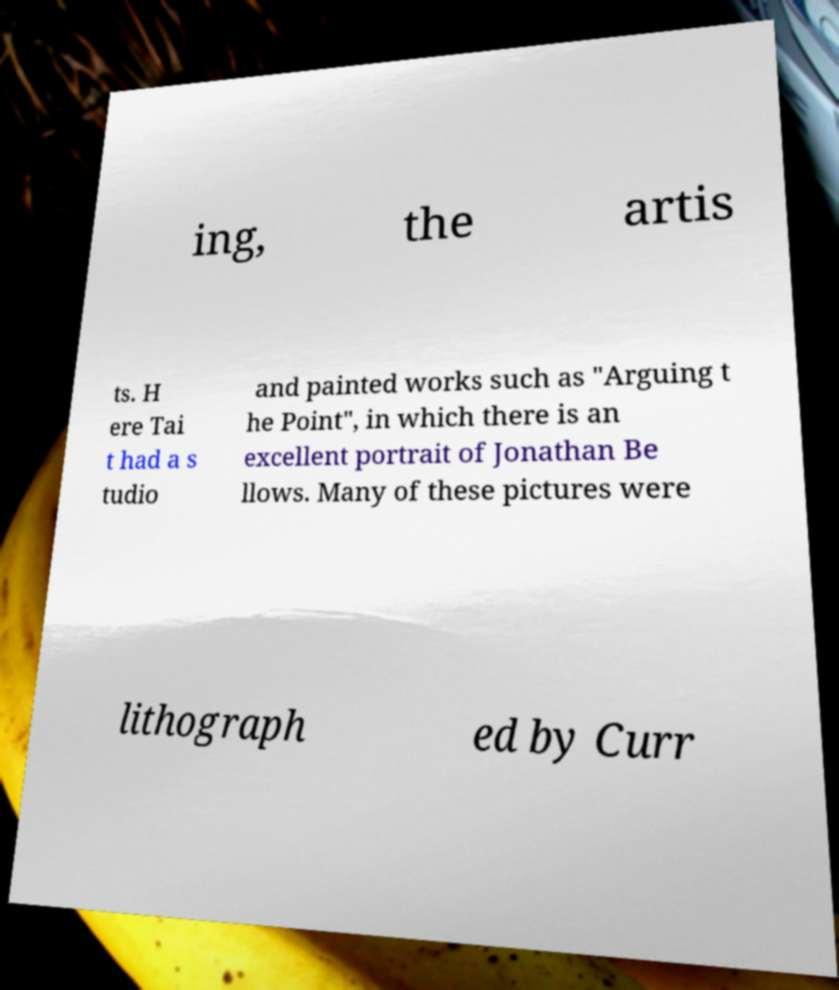Could you assist in decoding the text presented in this image and type it out clearly? ing, the artis ts. H ere Tai t had a s tudio and painted works such as "Arguing t he Point", in which there is an excellent portrait of Jonathan Be llows. Many of these pictures were lithograph ed by Curr 